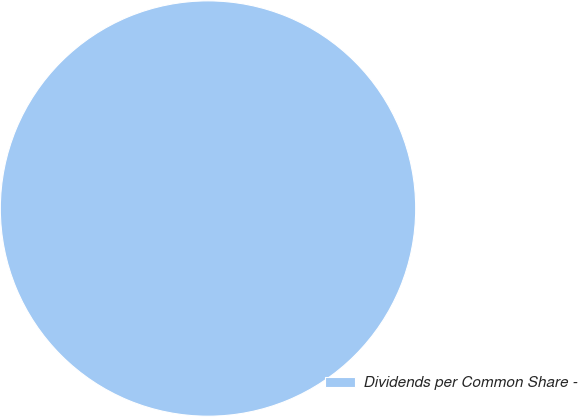<chart> <loc_0><loc_0><loc_500><loc_500><pie_chart><fcel>Dividends per Common Share -<nl><fcel>100.0%<nl></chart> 